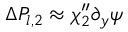Convert formula to latex. <formula><loc_0><loc_0><loc_500><loc_500>\Delta P _ { l , 2 } \approx \chi _ { 2 } ^ { \prime \prime } \partial _ { y } \psi</formula> 